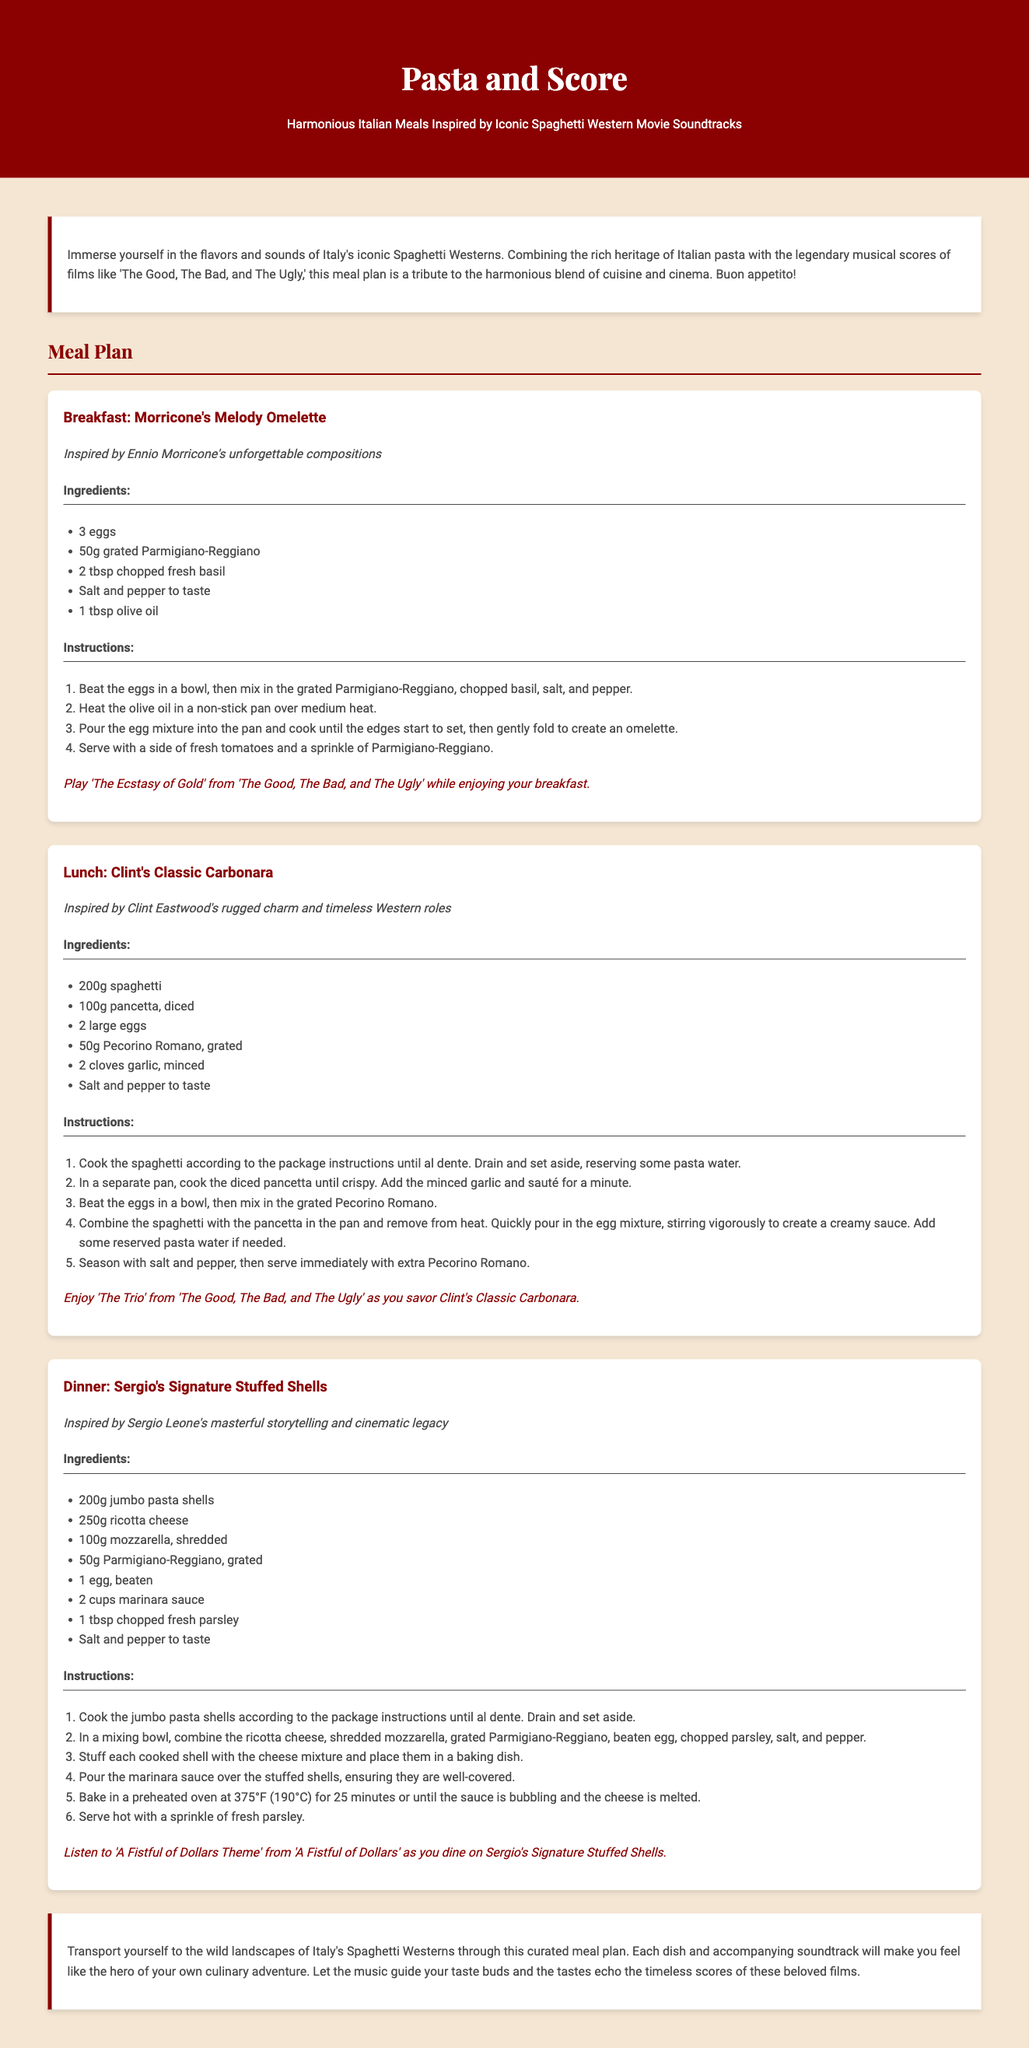What is the title of the meal plan? The title of the meal plan is stated in the header of the document.
Answer: Pasta and Score Who inspired the Breakfast meal? The Breakfast meal is inspired by a famous composer known for his film scores.
Answer: Ennio Morricone What is the main ingredient in Clint's Classic Carbonara? The main ingredient in Clint's Classic Carbonara, which is a type of pasta, is specified in the ingredients section.
Answer: spaghetti How many eggs are used in Morricone's Melody Omelette? The recipe for Morricone's Melody Omelette specifies the number of eggs in the ingredients list.
Answer: 3 eggs What soundtracks are associated with Sergio's Signature Stuffed Shells? The soundtrack associated with the dinner meal is indicated at the end of its section.
Answer: A Fistful of Dollars Theme Which dish includes pancetta? The dish that includes pancetta is mentioned in its title and ingredients.
Answer: Clint's Classic Carbonara What type of pasta is used for the Dinner meal? The type of pasta specified for the dinner dish is stated in the ingredients section.
Answer: jumbo pasta shells How long should you bake the stuffed shells? The baking time for Sergio's Signature Stuffed Shells is provided in the instructions.
Answer: 25 minutes 